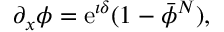Convert formula to latex. <formula><loc_0><loc_0><loc_500><loc_500>\partial _ { x } \phi = { \mathrm e } ^ { \imath \delta } ( 1 - \bar { \phi } ^ { N } ) ,</formula> 